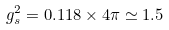Convert formula to latex. <formula><loc_0><loc_0><loc_500><loc_500>g _ { s } ^ { 2 } = 0 . 1 1 8 \times 4 \pi \simeq 1 . 5</formula> 